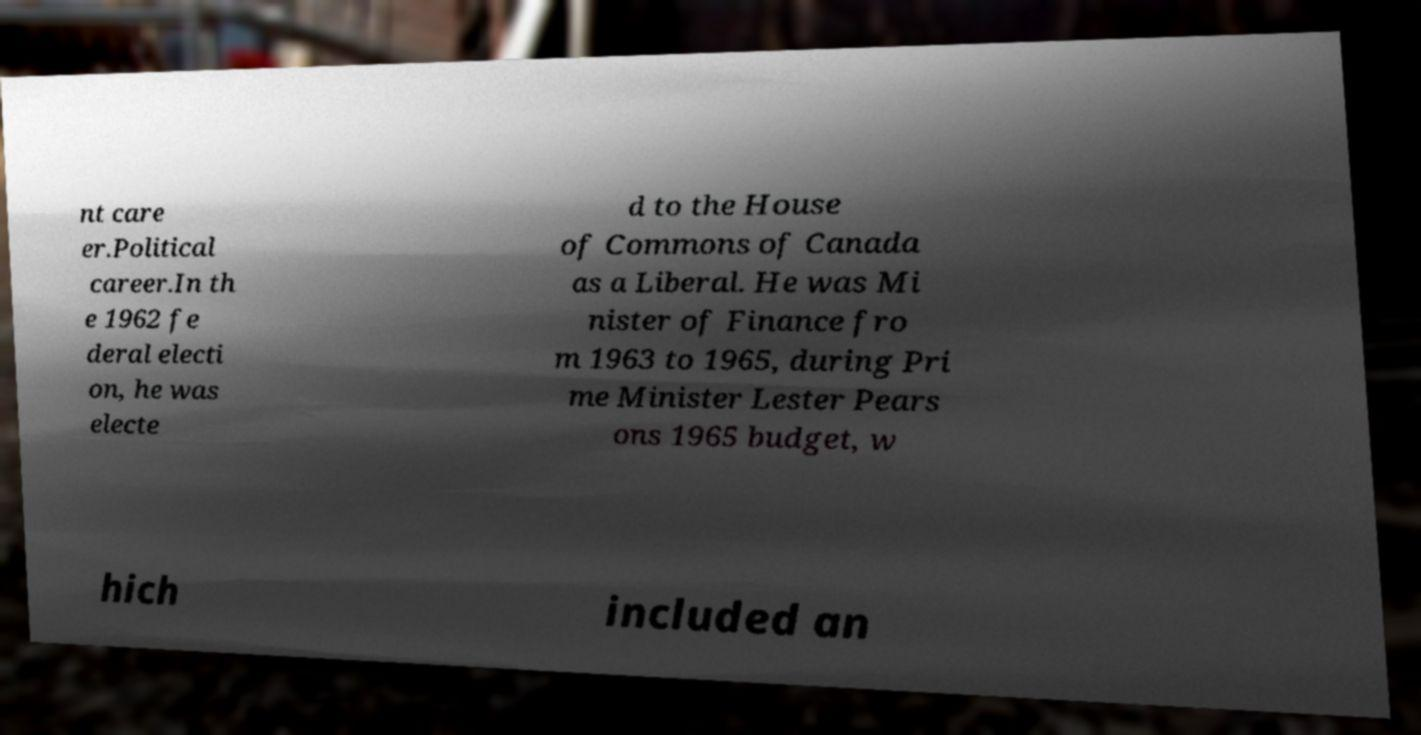Could you extract and type out the text from this image? nt care er.Political career.In th e 1962 fe deral electi on, he was electe d to the House of Commons of Canada as a Liberal. He was Mi nister of Finance fro m 1963 to 1965, during Pri me Minister Lester Pears ons 1965 budget, w hich included an 